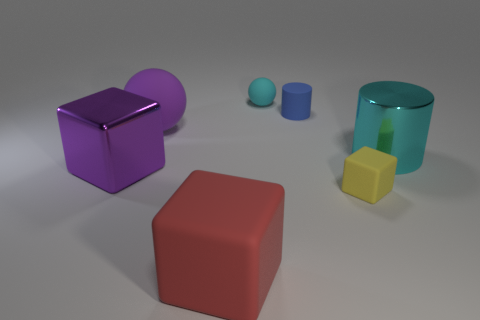Do the large shiny cylinder and the tiny ball have the same color?
Offer a terse response. Yes. There is a large metal cylinder; is its color the same as the rubber ball on the right side of the large sphere?
Make the answer very short. Yes. What shape is the shiny thing that is the same color as the small rubber ball?
Make the answer very short. Cylinder. How many other things are the same size as the cyan metal thing?
Keep it short and to the point. 3. Are there an equal number of cyan spheres that are to the left of the red rubber cube and small green spheres?
Your response must be concise. Yes. What number of tiny cubes have the same material as the blue object?
Give a very brief answer. 1. What is the color of the large cube that is the same material as the blue thing?
Offer a terse response. Red. Does the blue matte thing have the same shape as the big red matte thing?
Offer a terse response. No. Are there any tiny matte things right of the rubber ball behind the small blue object that is to the left of the small yellow cube?
Offer a very short reply. Yes. What number of rubber spheres have the same color as the shiny cylinder?
Your response must be concise. 1. 